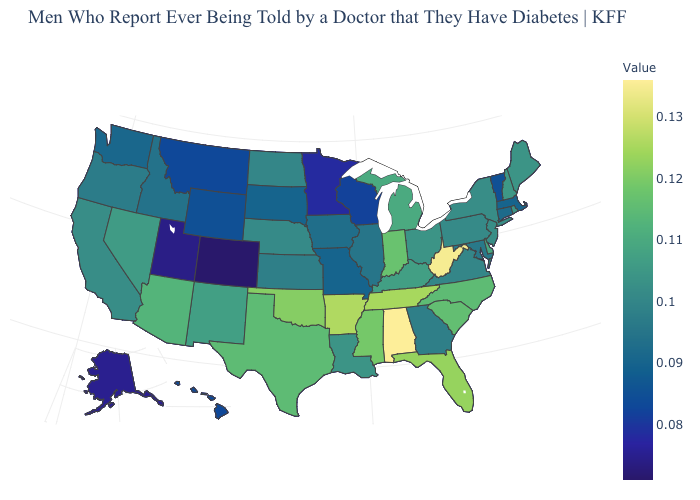Does Tennessee have the highest value in the South?
Keep it brief. No. Among the states that border Delaware , which have the lowest value?
Write a very short answer. Maryland. Does Oklahoma have the highest value in the South?
Quick response, please. No. 